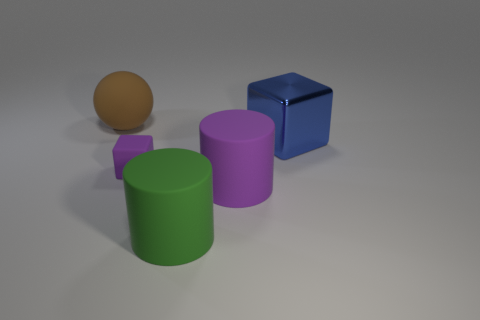Subtract 2 cylinders. How many cylinders are left? 0 Add 3 tiny blue blocks. How many objects exist? 8 Subtract all cubes. How many objects are left? 3 Add 3 large green things. How many large green things exist? 4 Subtract 0 gray cylinders. How many objects are left? 5 Subtract all yellow cubes. Subtract all purple cylinders. How many cubes are left? 2 Subtract all big matte balls. Subtract all large blue blocks. How many objects are left? 3 Add 5 tiny purple rubber cubes. How many tiny purple rubber cubes are left? 6 